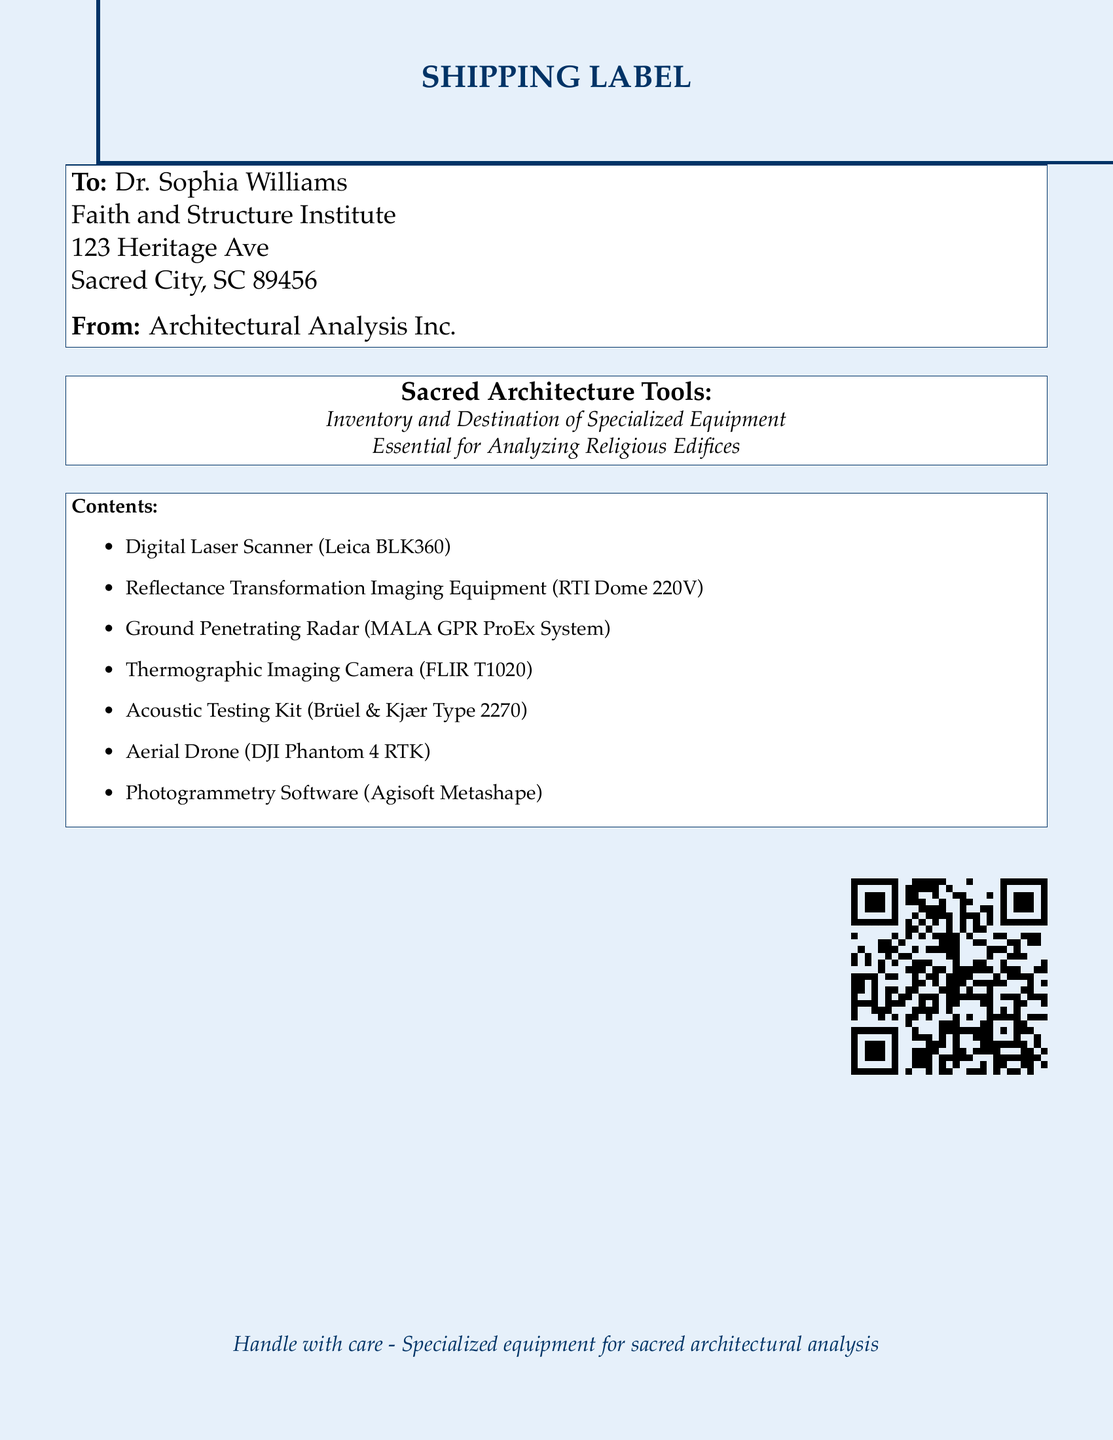What is the recipient's name? The recipient's name is listed in the shipping label under "To:" as Dr. Sophia Williams.
Answer: Dr. Sophia Williams What is the shipping destination? The shipping destination is indicated by the address provided in the document, specifying the institute and address.
Answer: 123 Heritage Ave, Sacred City, SC 89456 What is the sender's name? The sender's name is provided in the shipping label under "From:" and is Architectural Analysis Inc.
Answer: Architectural Analysis Inc How many items are listed in the contents? The document enumerates a list of specialized equipment categorized under "Contents," totaling to seven items indicated in bullet points.
Answer: 7 Which digital tool is mentioned for photogrammetry? The document lists "Photogrammetry Software" specifically denoted as Agisoft Metashape among the described tools.
Answer: Agisoft Metashape What type of camera is included in the equipment? The document mentions a camera that performs thermal imaging, specifically labeled as a Thermographic Imaging Camera.
Answer: FLIR T1020 What is one use of the Ground Penetrating Radar? The Ground Penetrating Radar is mentioned as a tool for analyzing religious edifices, and reasoning might lead to its use in locating foundational structures.
Answer: Analyzing foundations What does the document say regarding the handling of the equipment? The document includes a cautionary statement about the need to handle the specialized equipment with care, stressing its purpose.
Answer: Handle with care What link is provided for more information? The document features a QR code directing to a website, with its URL included, specifically tailored for accessing further details on the tools.
Answer: https://faithandstructure.org/sacredtools 